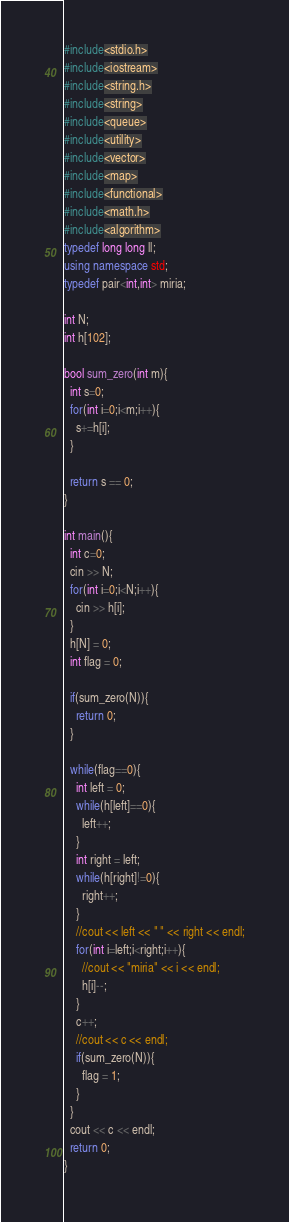<code> <loc_0><loc_0><loc_500><loc_500><_C++_>#include<stdio.h>
#include<iostream>
#include<string.h>
#include<string>
#include<queue>
#include<utility>
#include<vector>
#include<map>
#include<functional>
#include<math.h>
#include<algorithm>
typedef long long ll;
using namespace std;
typedef pair<int,int> miria;

int N;
int h[102];

bool sum_zero(int m){
  int s=0;
  for(int i=0;i<m;i++){
    s+=h[i];
  }

  return s == 0;
}

int main(){
  int c=0;
  cin >> N;
  for(int i=0;i<N;i++){
    cin >> h[i];
  }
  h[N] = 0;
  int flag = 0;

  if(sum_zero(N)){
    return 0;
  }

  while(flag==0){
    int left = 0;
    while(h[left]==0){
      left++;
    }
    int right = left;
    while(h[right]!=0){
      right++;
    }
    //cout << left << " " << right << endl;
    for(int i=left;i<right;i++){
      //cout << "miria" << i << endl;
      h[i]--;
    }
    c++;
    //cout << c << endl;
    if(sum_zero(N)){
      flag = 1;
    }
  }
  cout << c << endl;
  return 0;
}</code> 